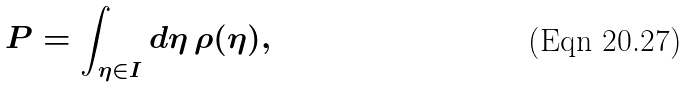Convert formula to latex. <formula><loc_0><loc_0><loc_500><loc_500>P = \int _ { \eta \in I } d \eta \, \rho ( \eta ) ,</formula> 